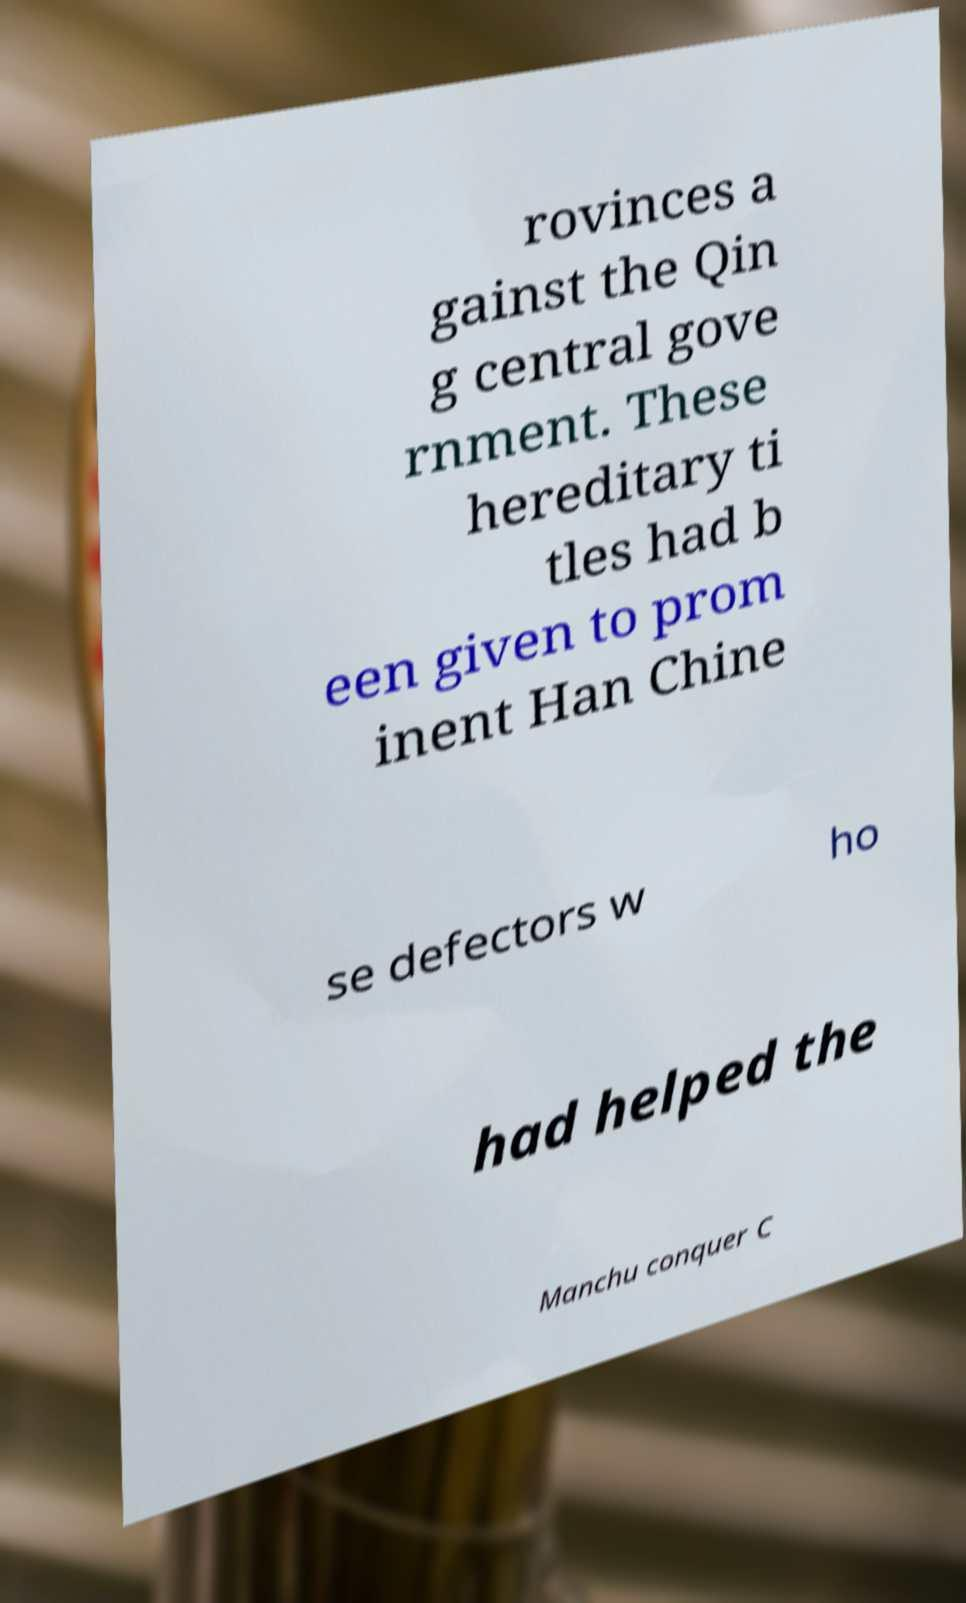There's text embedded in this image that I need extracted. Can you transcribe it verbatim? rovinces a gainst the Qin g central gove rnment. These hereditary ti tles had b een given to prom inent Han Chine se defectors w ho had helped the Manchu conquer C 